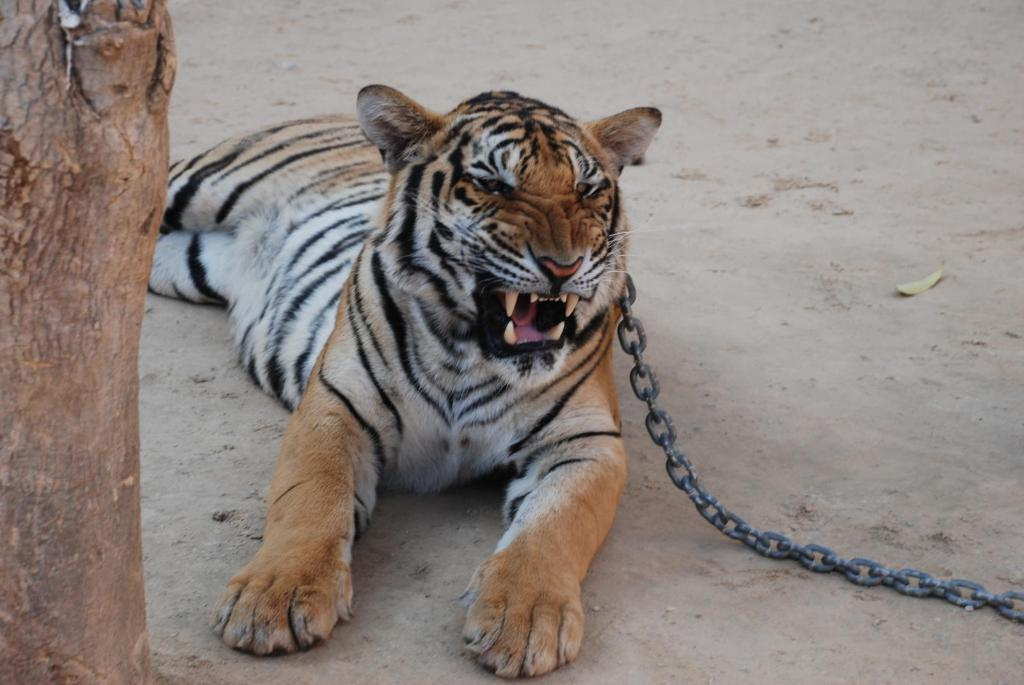What type of animal is in the image? There is a tiger in the image. Is the tiger restrained in any way? Yes, a chain is attached to the tiger's neck. What can be seen on the left side of the image? There is a wooden object visible on the left side of the image. How does the snail contribute to the thrill of the image? There is no snail present in the image, so it cannot contribute to the thrill or any aspect of the image. 